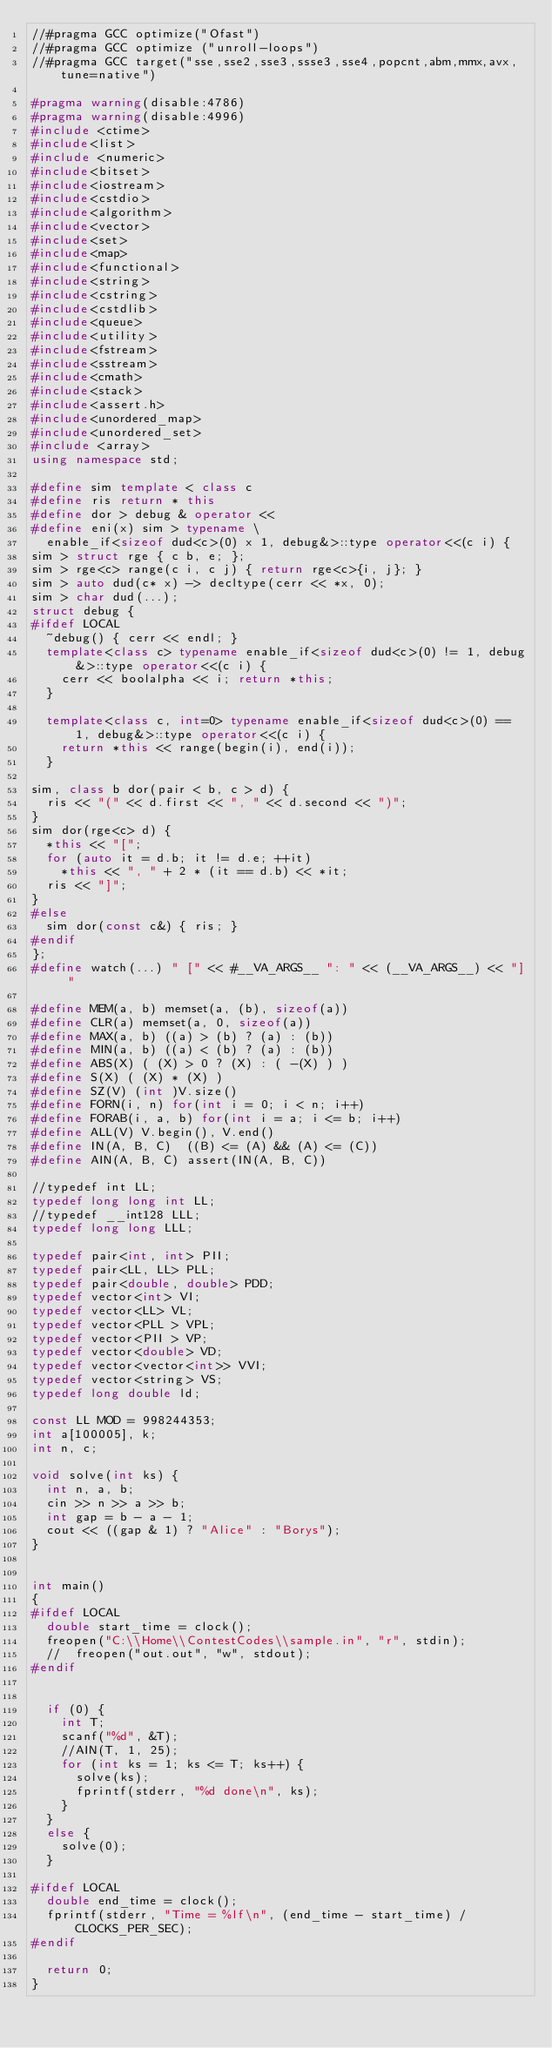Convert code to text. <code><loc_0><loc_0><loc_500><loc_500><_C++_>//#pragma GCC optimize("Ofast")
//#pragma GCC optimize ("unroll-loops")
//#pragma GCC target("sse,sse2,sse3,ssse3,sse4,popcnt,abm,mmx,avx,tune=native")

#pragma warning(disable:4786)
#pragma warning(disable:4996)
#include <ctime>
#include<list>
#include <numeric>
#include<bitset>
#include<iostream>
#include<cstdio>
#include<algorithm>
#include<vector>
#include<set>
#include<map>
#include<functional>
#include<string>
#include<cstring>
#include<cstdlib>
#include<queue>
#include<utility>
#include<fstream>
#include<sstream>
#include<cmath>
#include<stack>
#include<assert.h>
#include<unordered_map>
#include<unordered_set>
#include <array>
using namespace std;

#define sim template < class c
#define ris return * this
#define dor > debug & operator <<
#define eni(x) sim > typename \
  enable_if<sizeof dud<c>(0) x 1, debug&>::type operator<<(c i) {
sim > struct rge { c b, e; };
sim > rge<c> range(c i, c j) { return rge<c>{i, j}; }
sim > auto dud(c* x) -> decltype(cerr << *x, 0);
sim > char dud(...);
struct debug {
#ifdef LOCAL
	~debug() { cerr << endl; }
	template<class c> typename enable_if<sizeof dud<c>(0) != 1, debug&>::type operator<<(c i) {
		cerr << boolalpha << i; return *this;
	}

	template<class c, int=0> typename enable_if<sizeof dud<c>(0) == 1, debug&>::type operator<<(c i) {
		return *this << range(begin(i), end(i));
	}

sim, class b dor(pair < b, c > d) {
	ris << "(" << d.first << ", " << d.second << ")";
}
sim dor(rge<c> d) {
	*this << "[";
	for (auto it = d.b; it != d.e; ++it)
		*this << ", " + 2 * (it == d.b) << *it;
	ris << "]";
}
#else
	sim dor(const c&) { ris; }
#endif
};
#define watch(...) " [" << #__VA_ARGS__ ": " << (__VA_ARGS__) << "] "

#define MEM(a, b) memset(a, (b), sizeof(a))
#define CLR(a) memset(a, 0, sizeof(a))
#define MAX(a, b) ((a) > (b) ? (a) : (b))
#define MIN(a, b) ((a) < (b) ? (a) : (b))
#define ABS(X) ( (X) > 0 ? (X) : ( -(X) ) )
#define S(X) ( (X) * (X) )
#define SZ(V) (int )V.size()
#define FORN(i, n) for(int i = 0; i < n; i++)
#define FORAB(i, a, b) for(int i = a; i <= b; i++)
#define ALL(V) V.begin(), V.end()
#define IN(A, B, C)  ((B) <= (A) && (A) <= (C))
#define AIN(A, B, C) assert(IN(A, B, C))

//typedef int LL;
typedef long long int LL;
//typedef __int128 LLL;
typedef long long LLL;

typedef pair<int, int> PII;
typedef pair<LL, LL> PLL;
typedef pair<double, double> PDD;
typedef vector<int> VI;
typedef vector<LL> VL;
typedef vector<PLL > VPL;
typedef vector<PII > VP;
typedef vector<double> VD;
typedef vector<vector<int>> VVI;
typedef vector<string> VS;
typedef long double ld;

const LL MOD = 998244353;
int a[100005], k;
int n, c;

void solve(int ks) {
	int n, a, b;
	cin >> n >> a >> b;
	int gap = b - a - 1;
	cout << ((gap & 1) ? "Alice" : "Borys");
}


int main()
{
#ifdef LOCAL
	double start_time = clock();
	freopen("C:\\Home\\ContestCodes\\sample.in", "r", stdin);
	//	freopen("out.out", "w", stdout);
#endif


	if (0) {
		int T;
		scanf("%d", &T);
		//AIN(T, 1, 25);
		for (int ks = 1; ks <= T; ks++) {
			solve(ks);
			fprintf(stderr, "%d done\n", ks);
		}
	}
	else {
		solve(0);
	}

#ifdef LOCAL
	double end_time = clock();
	fprintf(stderr, "Time = %lf\n", (end_time - start_time) / CLOCKS_PER_SEC);
#endif

	return 0;
}
</code> 